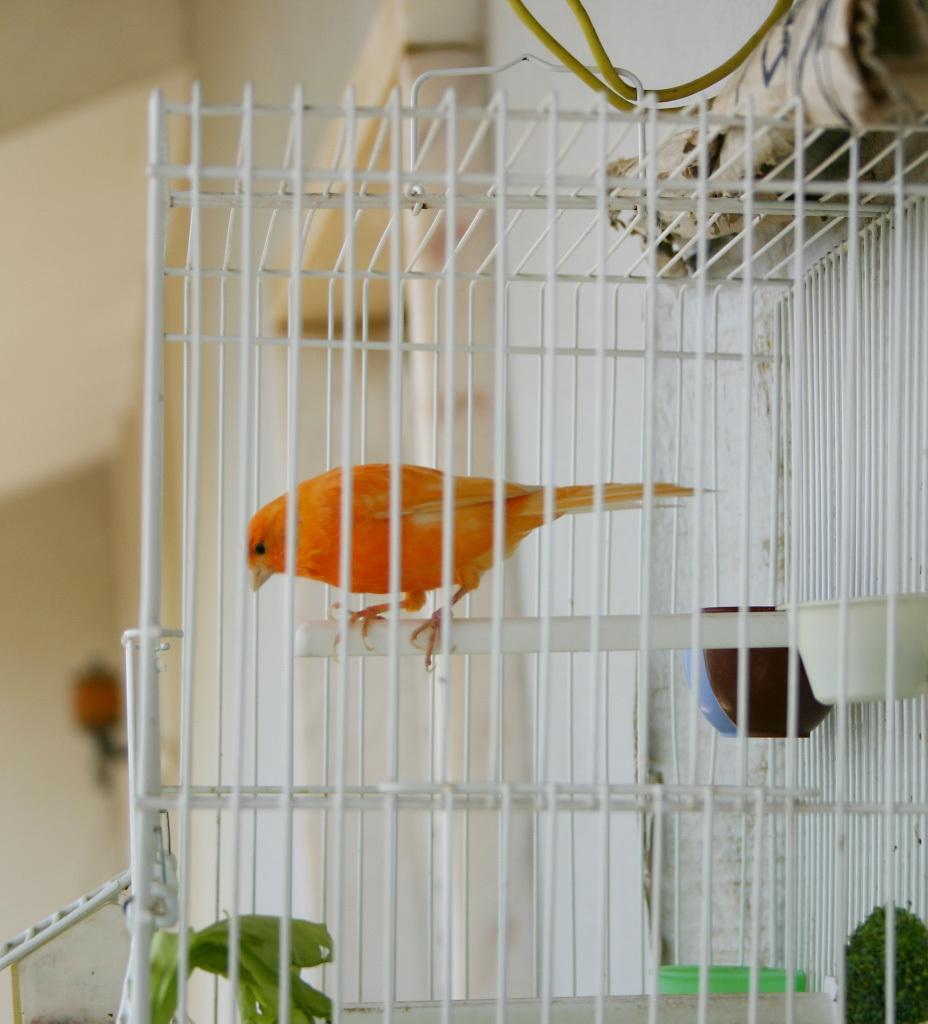Please provide a concise description of this image. In this image there is a bird in the cage having few bowls attached to the metal rods. Background there is a wall having a lamp attached to it. 